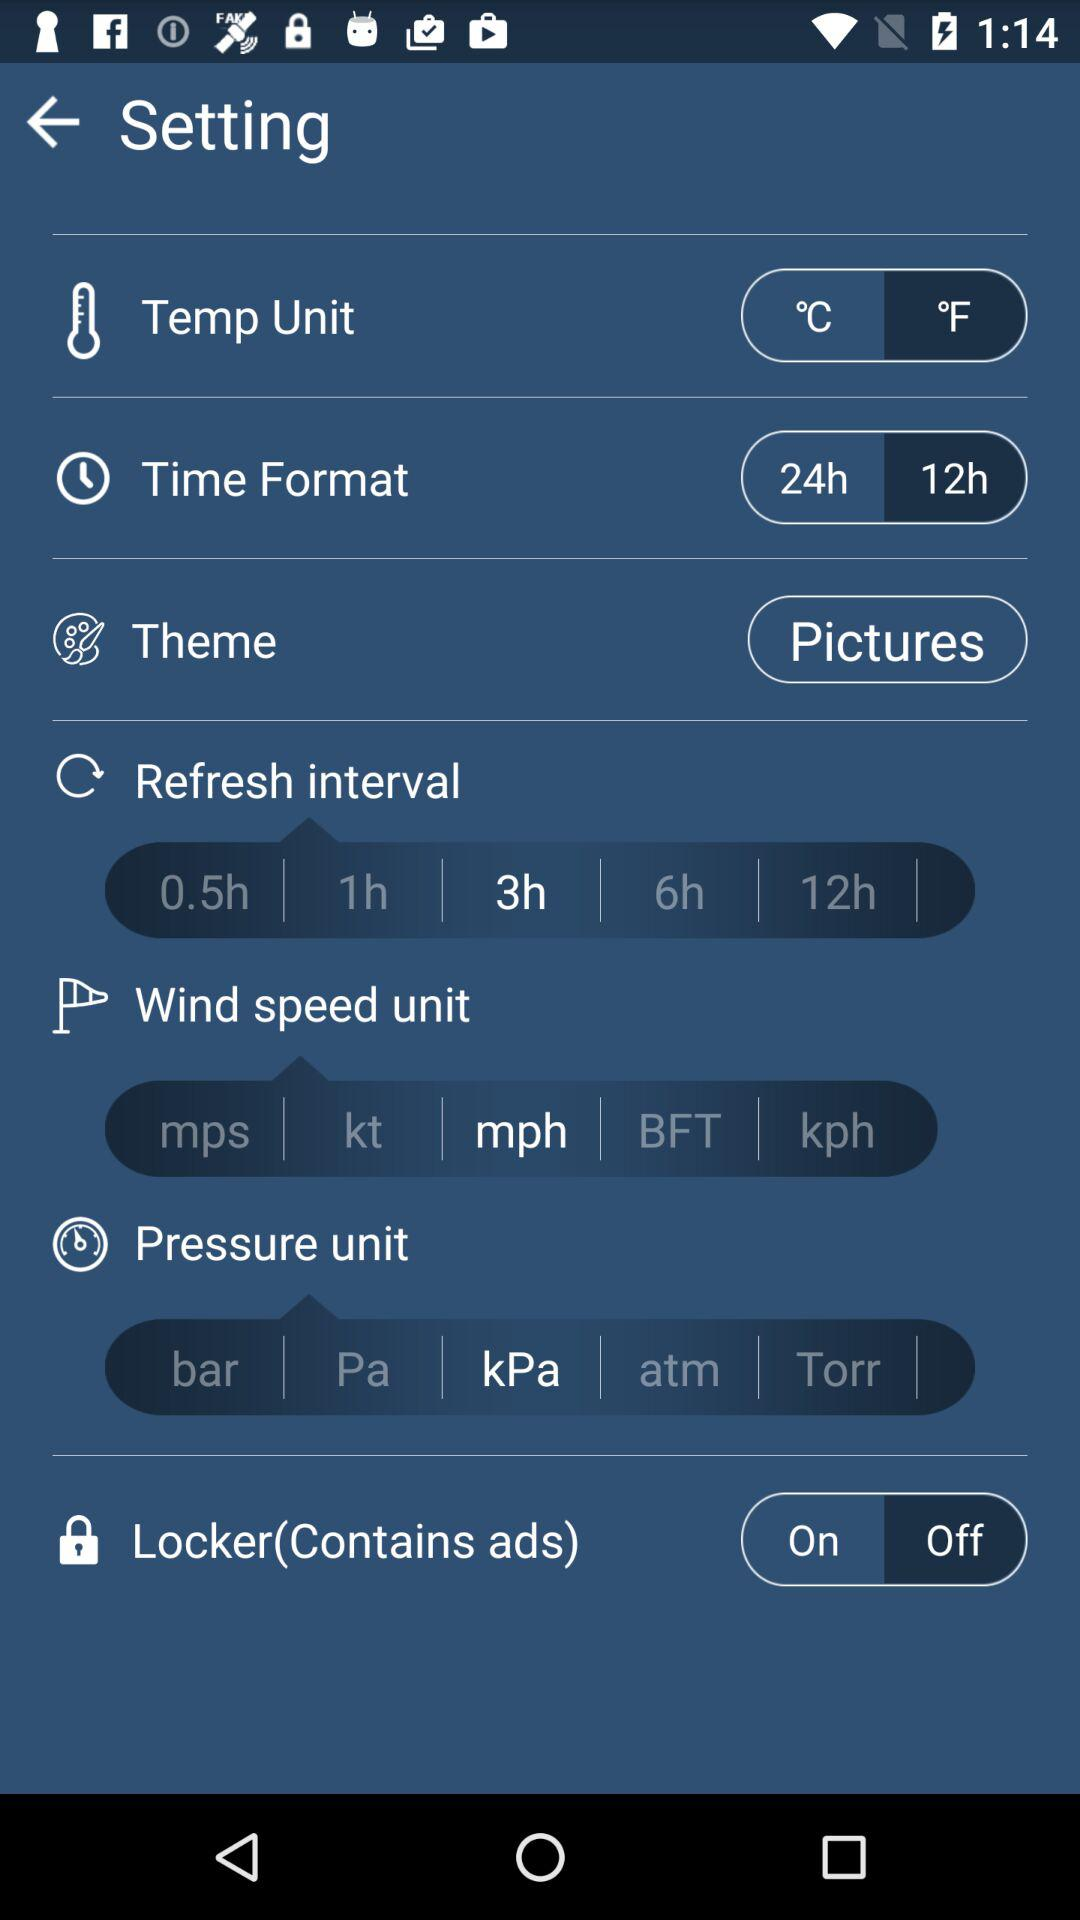What is the time format? The time format is 24 hours. 